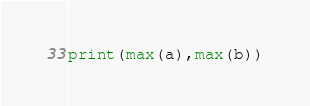Convert code to text. <code><loc_0><loc_0><loc_500><loc_500><_Python_>print(max(a),max(b))
</code> 